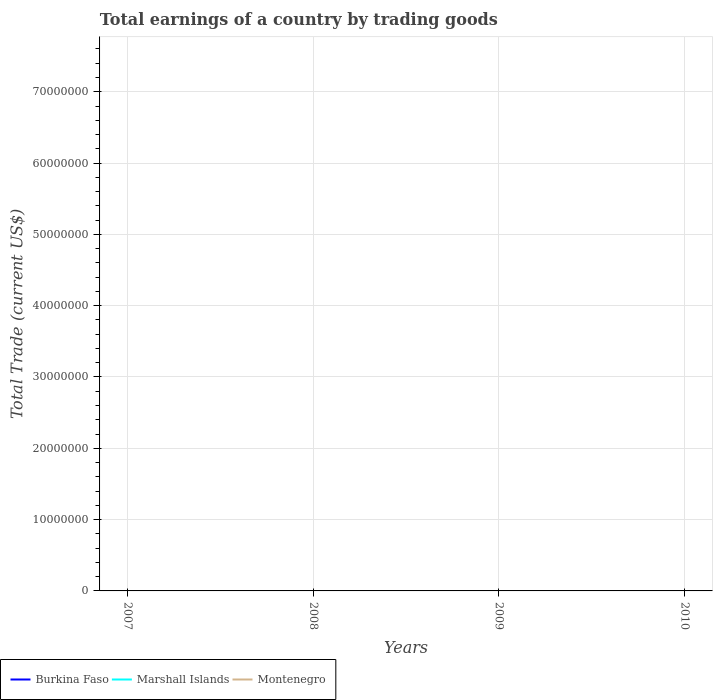Is the number of lines equal to the number of legend labels?
Ensure brevity in your answer.  No. Across all years, what is the maximum total earnings in Montenegro?
Provide a succinct answer. 0. What is the difference between the highest and the lowest total earnings in Burkina Faso?
Provide a succinct answer. 0. How many lines are there?
Offer a terse response. 0. What is the difference between two consecutive major ticks on the Y-axis?
Offer a very short reply. 1.00e+07. Are the values on the major ticks of Y-axis written in scientific E-notation?
Provide a succinct answer. No. Does the graph contain grids?
Your answer should be very brief. Yes. Where does the legend appear in the graph?
Your answer should be very brief. Bottom left. How many legend labels are there?
Your answer should be very brief. 3. What is the title of the graph?
Your answer should be compact. Total earnings of a country by trading goods. What is the label or title of the X-axis?
Offer a very short reply. Years. What is the label or title of the Y-axis?
Provide a succinct answer. Total Trade (current US$). What is the Total Trade (current US$) of Burkina Faso in 2007?
Make the answer very short. 0. What is the Total Trade (current US$) of Marshall Islands in 2009?
Keep it short and to the point. 0. What is the Total Trade (current US$) in Burkina Faso in 2010?
Keep it short and to the point. 0. What is the total Total Trade (current US$) in Marshall Islands in the graph?
Keep it short and to the point. 0. What is the total Total Trade (current US$) in Montenegro in the graph?
Ensure brevity in your answer.  0. What is the average Total Trade (current US$) in Burkina Faso per year?
Keep it short and to the point. 0. 